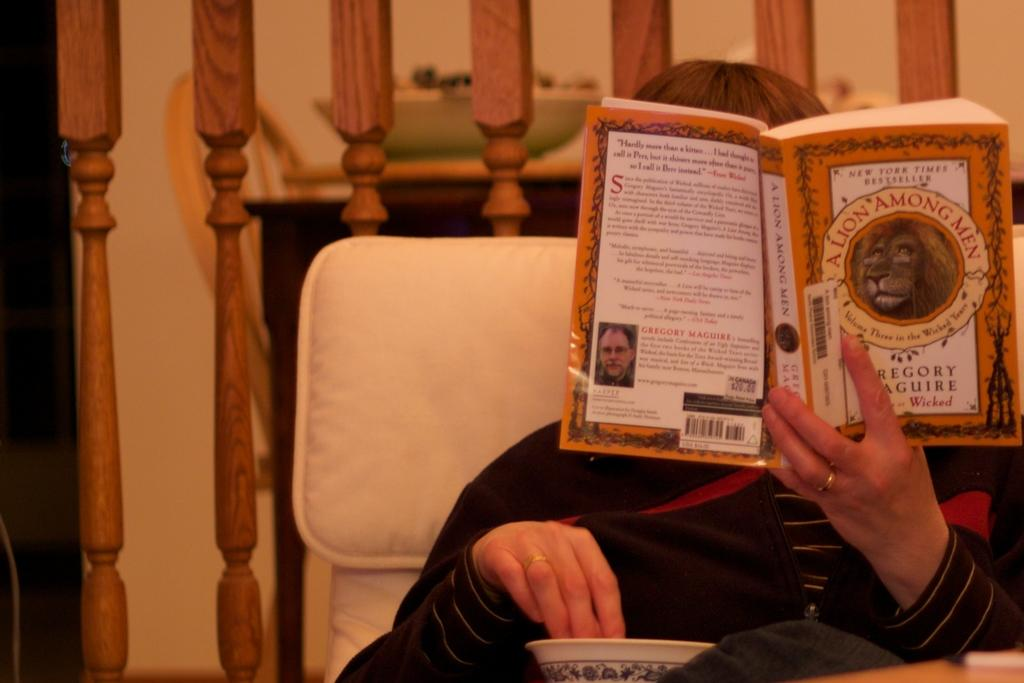<image>
Provide a brief description of the given image. The person seated is reading the book A lion among men. 